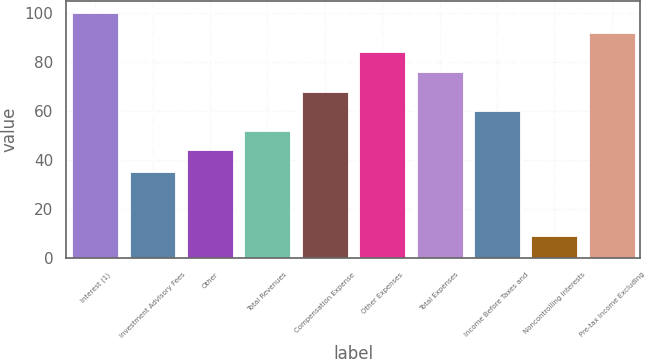Convert chart to OTSL. <chart><loc_0><loc_0><loc_500><loc_500><bar_chart><fcel>Interest (1)<fcel>Investment Advisory Fees<fcel>Other<fcel>Total Revenues<fcel>Compensation Expense<fcel>Other Expenses<fcel>Total Expenses<fcel>Income Before Taxes and<fcel>Noncontrolling Interests<fcel>Pre-tax Income Excluding<nl><fcel>100<fcel>35<fcel>44<fcel>52<fcel>68<fcel>84<fcel>76<fcel>60<fcel>9<fcel>92<nl></chart> 